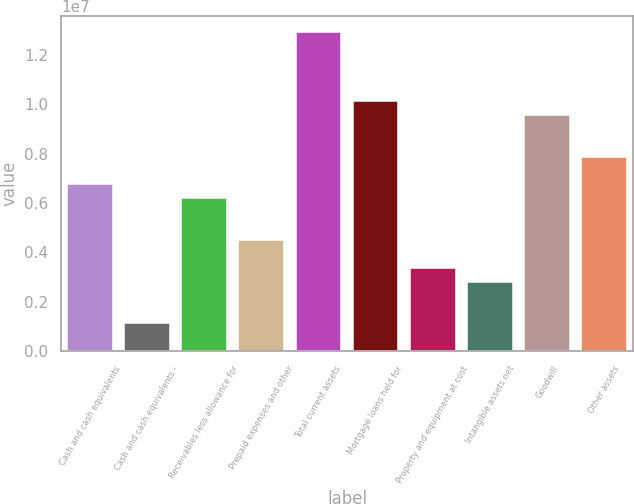<chart> <loc_0><loc_0><loc_500><loc_500><bar_chart><fcel>Cash and cash equivalents<fcel>Cash and cash equivalents -<fcel>Receivables less allowance for<fcel>Prepaid expenses and other<fcel>Total current assets<fcel>Mortgage loans held for<fcel>Property and equipment at cost<fcel>Intangible assets net<fcel>Goodwill<fcel>Other assets<nl><fcel>6.74761e+06<fcel>1.12667e+06<fcel>6.18552e+06<fcel>4.49924e+06<fcel>1.29306e+07<fcel>1.01202e+07<fcel>3.37505e+06<fcel>2.81296e+06<fcel>9.55808e+06<fcel>7.8718e+06<nl></chart> 